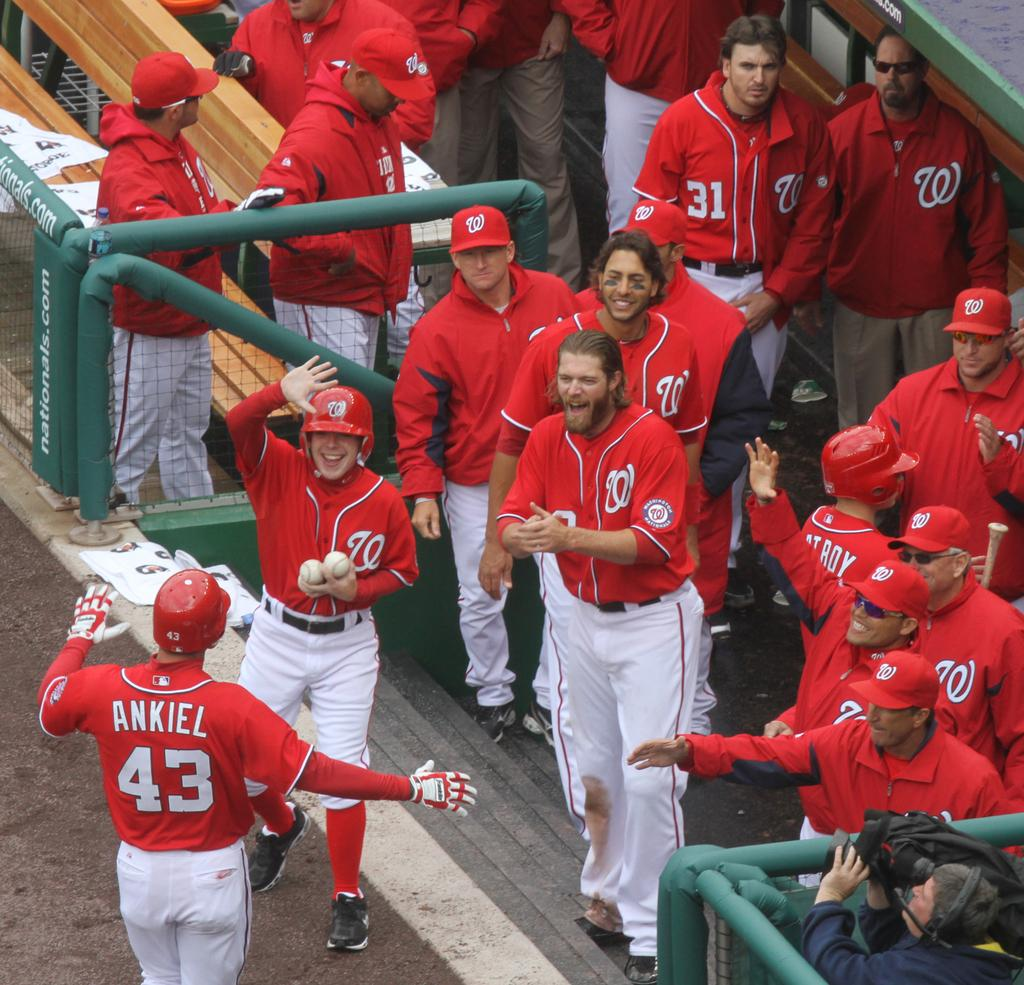<image>
Relay a brief, clear account of the picture shown. The player ankiel stands facing all his team while they cheer and celebrate. 